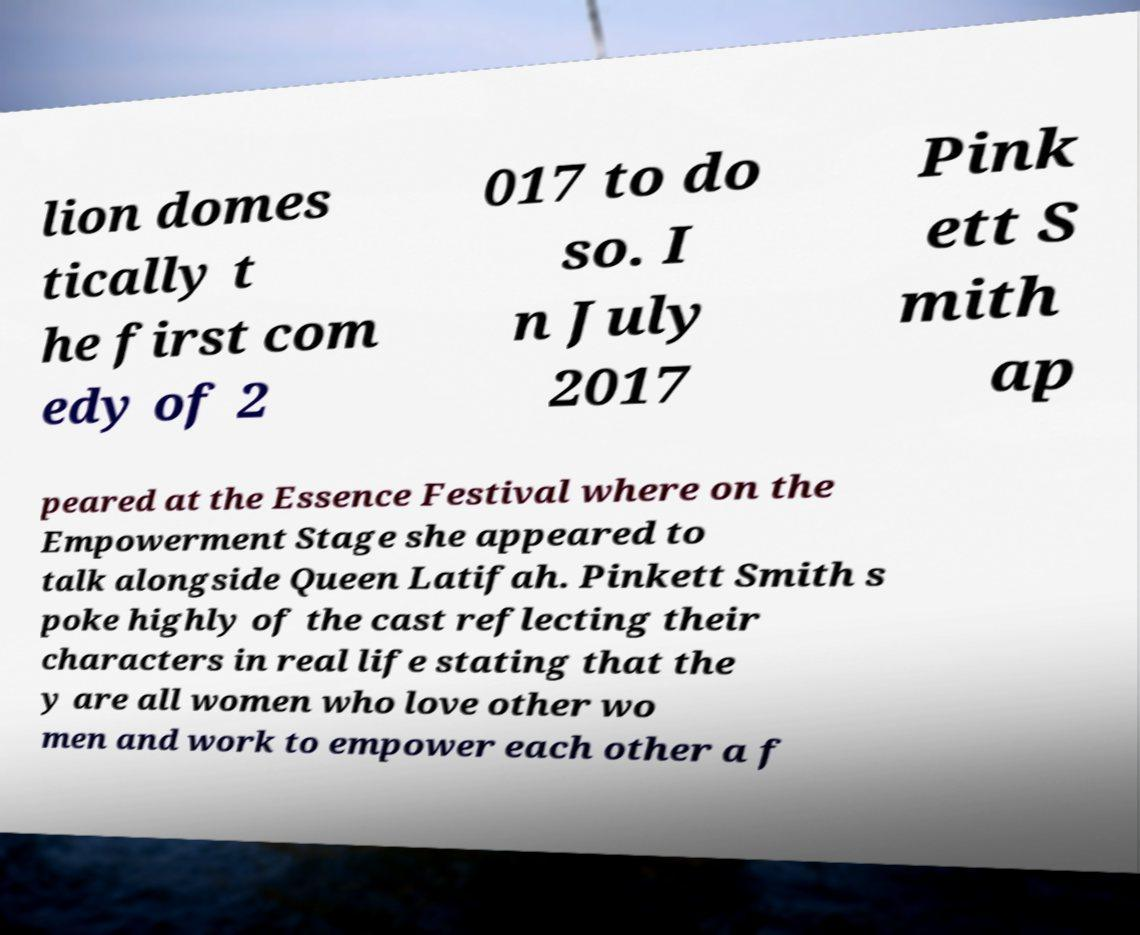Please read and relay the text visible in this image. What does it say? lion domes tically t he first com edy of 2 017 to do so. I n July 2017 Pink ett S mith ap peared at the Essence Festival where on the Empowerment Stage she appeared to talk alongside Queen Latifah. Pinkett Smith s poke highly of the cast reflecting their characters in real life stating that the y are all women who love other wo men and work to empower each other a f 